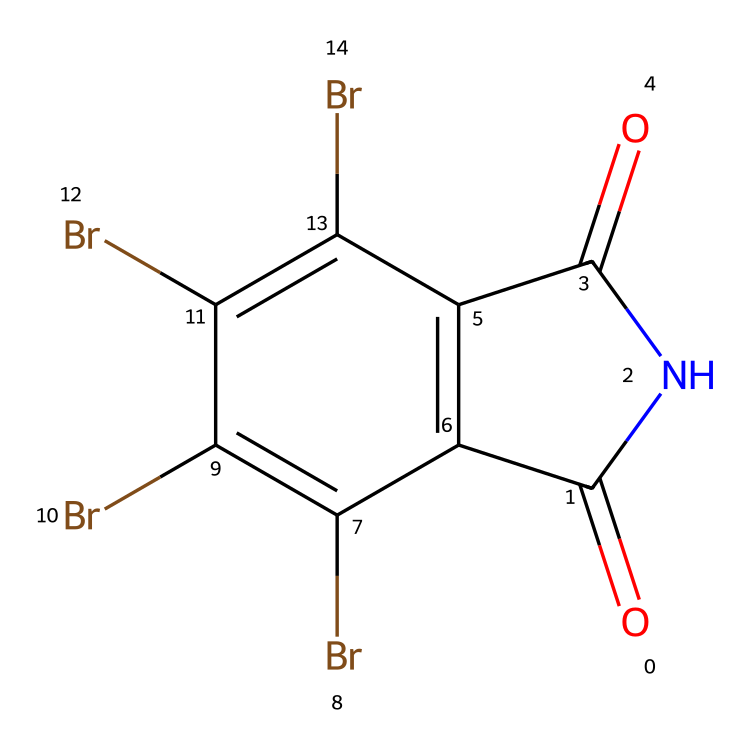How many bromine atoms are present in this chemical? By examining the SMILES representation, we can see the "Br" notation appears multiple times. Counting these occurrences shows there are four bromine atoms attached to the aromatic ring.
Answer: four What type of bonds are present between the carbon and nitrogen atoms? In the structure, the connection between the carbon and nitrogen is characterized by a double bond, indicated by the "=" symbol in the SMILES. This suggests a carbon-nitrogen double bond typical of imides.
Answer: double What is the functional group represented in this chemical structure? The presence of both carbonyl (C=O) and nitrogen (N) in a cyclic structure indicates that this compound belongs to the imide functional group, which is defined by its carbonyls adjacent to the nitrogen atom.
Answer: imide How many rings are there in the structure of this chemical? Looking at the SMILES, there is a fused ring system. The notation reveals a primary cycle with additional cyclic structure involving two interconnected cycles. Counting these gives us one main ring and one additional fused structure.
Answer: two What is the total number of carbon atoms in the structure? Counting the carbon atoms in the structure from the SMILES provides a clear number. Each "c" (aromatic carbon) and the two "C" (alongside the two carbonyls) must be tallied. This totals to six carbon atoms in the molecule.
Answer: six Is the compound likely to be soluble in water? Given the significant presence of hydrophobic bromine atoms and the fact that imides generally do not have strong polar character, the molecule is expected to be less soluble in water.
Answer: no Does this chemical exhibit any flame-retardant properties? The presence of bromine atoms is characteristic of flame retardants, as bromine confers properties that inhibit combustion. Given this, the chemical likely exhibits flame-retardant characteristics.
Answer: yes 